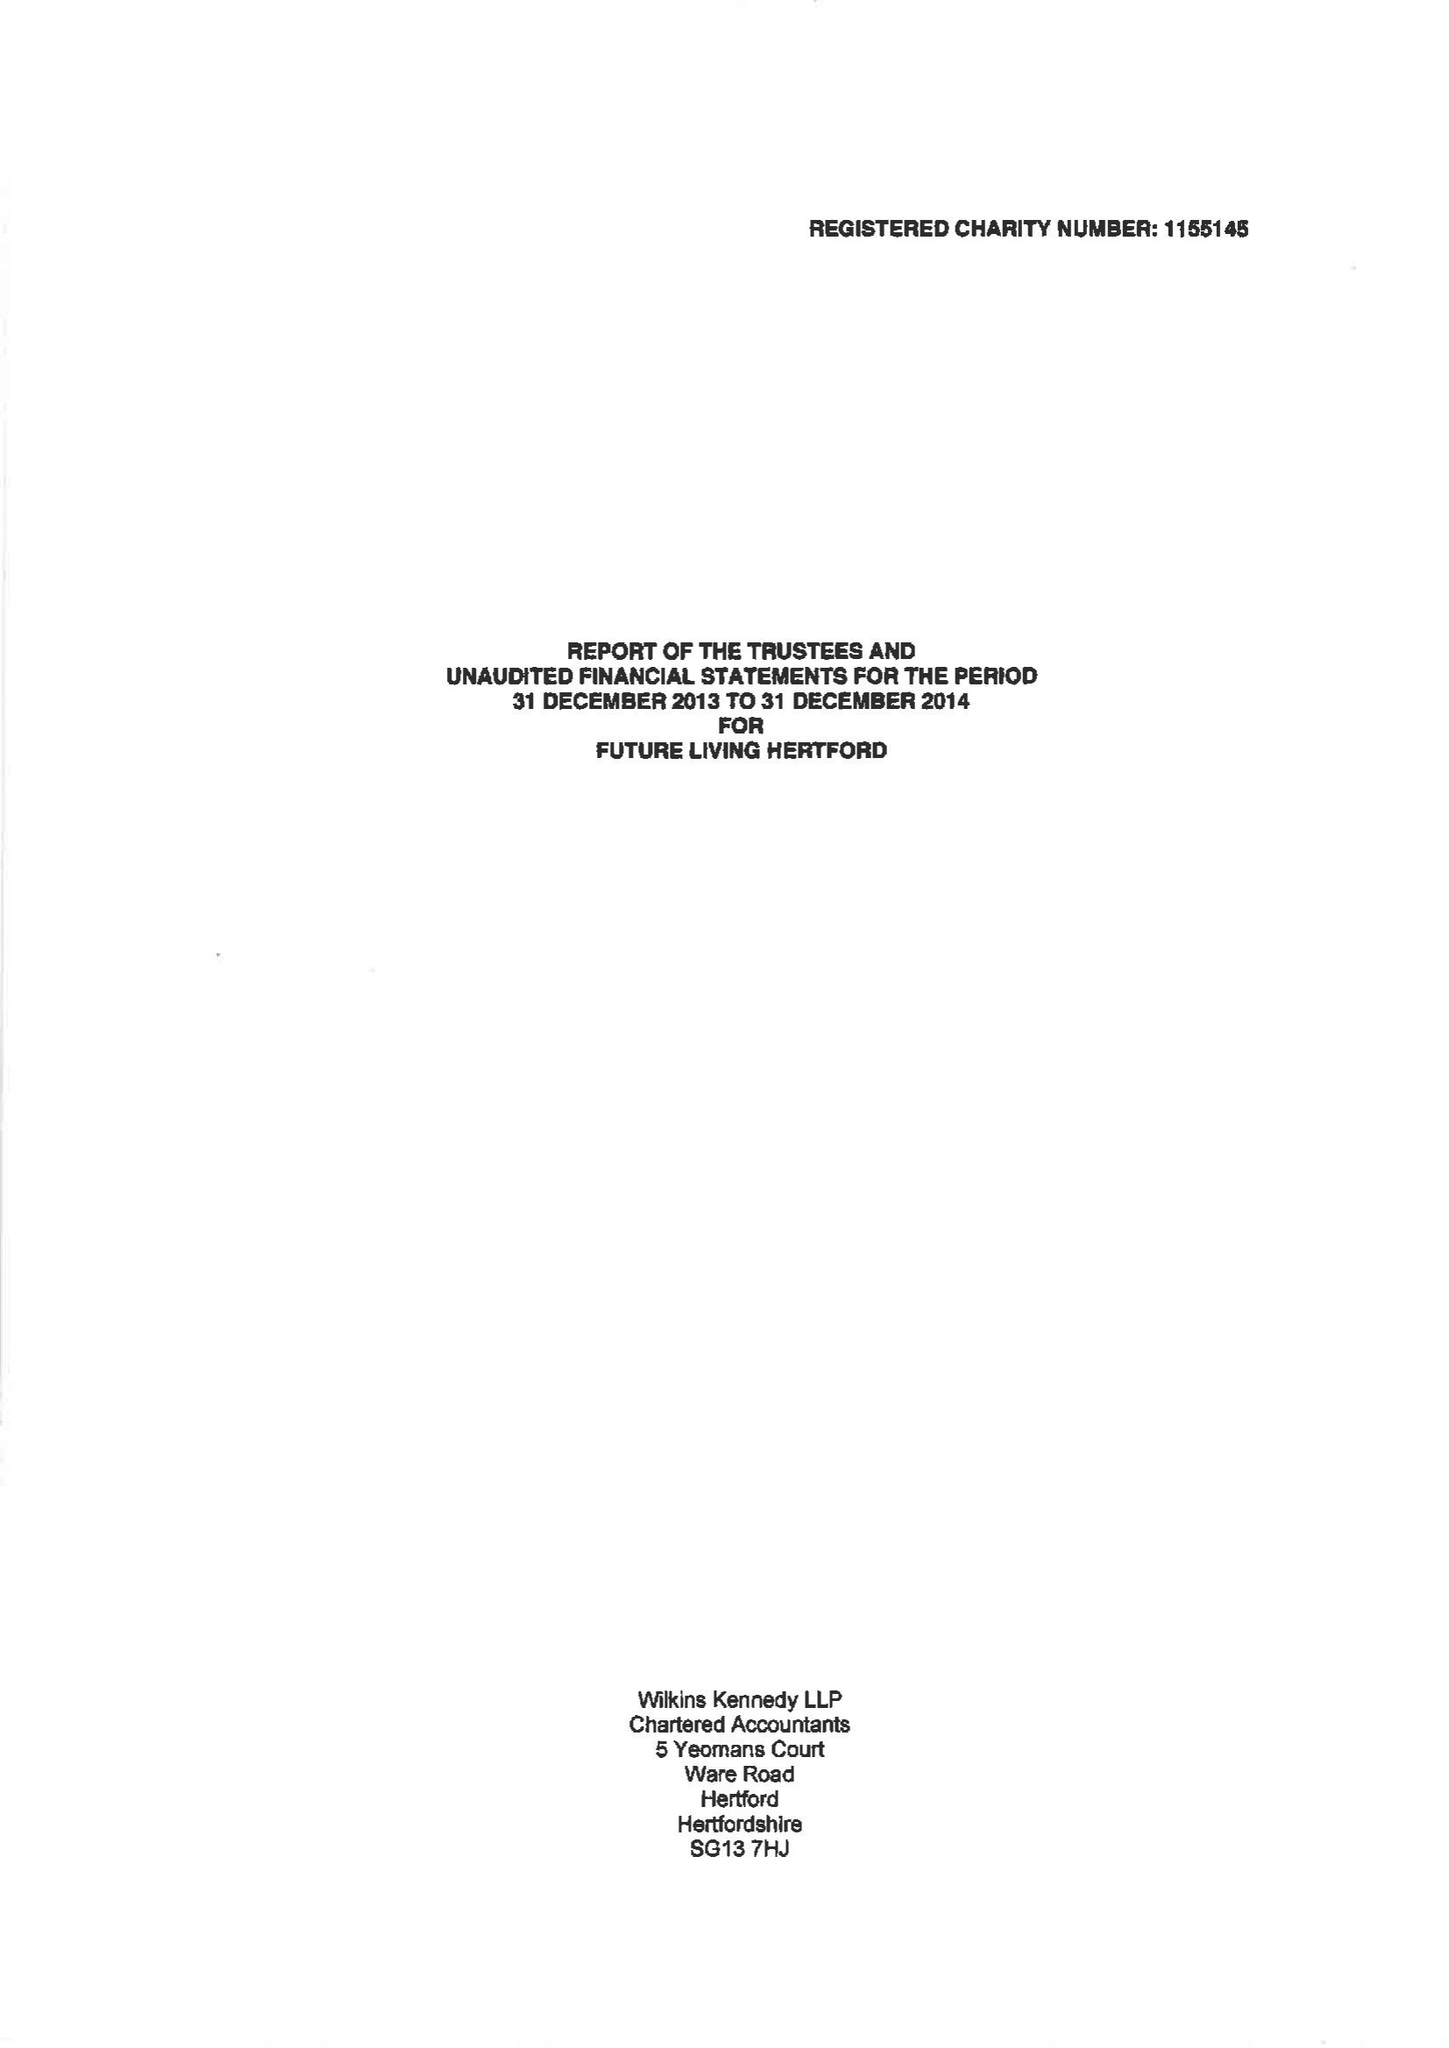What is the value for the address__street_line?
Answer the question using a single word or phrase. 43 COWBRIDGE 